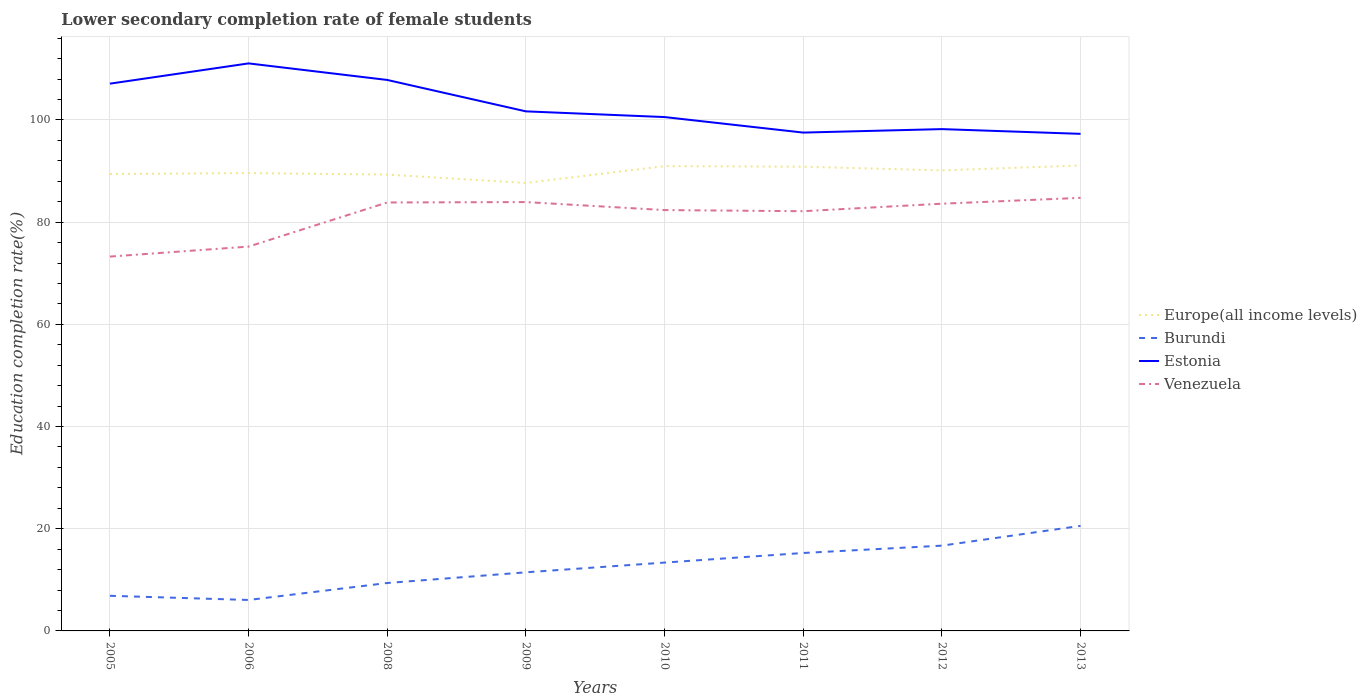Is the number of lines equal to the number of legend labels?
Keep it short and to the point. Yes. Across all years, what is the maximum lower secondary completion rate of female students in Venezuela?
Your response must be concise. 73.26. What is the total lower secondary completion rate of female students in Burundi in the graph?
Offer a very short reply. -5.41. What is the difference between the highest and the second highest lower secondary completion rate of female students in Burundi?
Offer a terse response. 14.5. How many lines are there?
Make the answer very short. 4. Where does the legend appear in the graph?
Offer a very short reply. Center right. How are the legend labels stacked?
Make the answer very short. Vertical. What is the title of the graph?
Your answer should be very brief. Lower secondary completion rate of female students. What is the label or title of the X-axis?
Give a very brief answer. Years. What is the label or title of the Y-axis?
Provide a succinct answer. Education completion rate(%). What is the Education completion rate(%) in Europe(all income levels) in 2005?
Provide a succinct answer. 89.41. What is the Education completion rate(%) in Burundi in 2005?
Make the answer very short. 6.87. What is the Education completion rate(%) in Estonia in 2005?
Your answer should be compact. 107.1. What is the Education completion rate(%) in Venezuela in 2005?
Your answer should be compact. 73.26. What is the Education completion rate(%) in Europe(all income levels) in 2006?
Make the answer very short. 89.6. What is the Education completion rate(%) of Burundi in 2006?
Make the answer very short. 6.06. What is the Education completion rate(%) of Estonia in 2006?
Offer a very short reply. 111.06. What is the Education completion rate(%) of Venezuela in 2006?
Offer a very short reply. 75.21. What is the Education completion rate(%) in Europe(all income levels) in 2008?
Your answer should be compact. 89.31. What is the Education completion rate(%) in Burundi in 2008?
Give a very brief answer. 9.38. What is the Education completion rate(%) in Estonia in 2008?
Offer a very short reply. 107.82. What is the Education completion rate(%) in Venezuela in 2008?
Provide a succinct answer. 83.84. What is the Education completion rate(%) of Europe(all income levels) in 2009?
Give a very brief answer. 87.66. What is the Education completion rate(%) in Burundi in 2009?
Ensure brevity in your answer.  11.47. What is the Education completion rate(%) in Estonia in 2009?
Keep it short and to the point. 101.68. What is the Education completion rate(%) in Venezuela in 2009?
Make the answer very short. 83.92. What is the Education completion rate(%) in Europe(all income levels) in 2010?
Offer a terse response. 90.96. What is the Education completion rate(%) of Burundi in 2010?
Your answer should be compact. 13.37. What is the Education completion rate(%) of Estonia in 2010?
Provide a succinct answer. 100.56. What is the Education completion rate(%) of Venezuela in 2010?
Your answer should be very brief. 82.36. What is the Education completion rate(%) in Europe(all income levels) in 2011?
Ensure brevity in your answer.  90.84. What is the Education completion rate(%) in Burundi in 2011?
Offer a terse response. 15.25. What is the Education completion rate(%) in Estonia in 2011?
Offer a terse response. 97.52. What is the Education completion rate(%) of Venezuela in 2011?
Keep it short and to the point. 82.14. What is the Education completion rate(%) of Europe(all income levels) in 2012?
Give a very brief answer. 90.13. What is the Education completion rate(%) of Burundi in 2012?
Keep it short and to the point. 16.69. What is the Education completion rate(%) of Estonia in 2012?
Provide a short and direct response. 98.2. What is the Education completion rate(%) of Venezuela in 2012?
Keep it short and to the point. 83.61. What is the Education completion rate(%) of Europe(all income levels) in 2013?
Offer a terse response. 91.08. What is the Education completion rate(%) of Burundi in 2013?
Make the answer very short. 20.56. What is the Education completion rate(%) of Estonia in 2013?
Make the answer very short. 97.27. What is the Education completion rate(%) in Venezuela in 2013?
Your answer should be very brief. 84.75. Across all years, what is the maximum Education completion rate(%) of Europe(all income levels)?
Your answer should be compact. 91.08. Across all years, what is the maximum Education completion rate(%) of Burundi?
Ensure brevity in your answer.  20.56. Across all years, what is the maximum Education completion rate(%) of Estonia?
Ensure brevity in your answer.  111.06. Across all years, what is the maximum Education completion rate(%) of Venezuela?
Provide a short and direct response. 84.75. Across all years, what is the minimum Education completion rate(%) in Europe(all income levels)?
Ensure brevity in your answer.  87.66. Across all years, what is the minimum Education completion rate(%) in Burundi?
Your answer should be very brief. 6.06. Across all years, what is the minimum Education completion rate(%) of Estonia?
Your response must be concise. 97.27. Across all years, what is the minimum Education completion rate(%) of Venezuela?
Provide a succinct answer. 73.26. What is the total Education completion rate(%) in Europe(all income levels) in the graph?
Your response must be concise. 718.99. What is the total Education completion rate(%) of Burundi in the graph?
Provide a succinct answer. 99.65. What is the total Education completion rate(%) of Estonia in the graph?
Offer a very short reply. 821.22. What is the total Education completion rate(%) of Venezuela in the graph?
Provide a succinct answer. 649.09. What is the difference between the Education completion rate(%) in Europe(all income levels) in 2005 and that in 2006?
Keep it short and to the point. -0.19. What is the difference between the Education completion rate(%) of Burundi in 2005 and that in 2006?
Ensure brevity in your answer.  0.82. What is the difference between the Education completion rate(%) of Estonia in 2005 and that in 2006?
Offer a very short reply. -3.96. What is the difference between the Education completion rate(%) in Venezuela in 2005 and that in 2006?
Make the answer very short. -1.95. What is the difference between the Education completion rate(%) of Europe(all income levels) in 2005 and that in 2008?
Your answer should be compact. 0.11. What is the difference between the Education completion rate(%) in Burundi in 2005 and that in 2008?
Provide a short and direct response. -2.5. What is the difference between the Education completion rate(%) of Estonia in 2005 and that in 2008?
Provide a short and direct response. -0.73. What is the difference between the Education completion rate(%) in Venezuela in 2005 and that in 2008?
Provide a short and direct response. -10.59. What is the difference between the Education completion rate(%) in Europe(all income levels) in 2005 and that in 2009?
Make the answer very short. 1.75. What is the difference between the Education completion rate(%) of Burundi in 2005 and that in 2009?
Your answer should be very brief. -4.6. What is the difference between the Education completion rate(%) in Estonia in 2005 and that in 2009?
Provide a succinct answer. 5.42. What is the difference between the Education completion rate(%) of Venezuela in 2005 and that in 2009?
Offer a terse response. -10.66. What is the difference between the Education completion rate(%) in Europe(all income levels) in 2005 and that in 2010?
Provide a succinct answer. -1.55. What is the difference between the Education completion rate(%) of Burundi in 2005 and that in 2010?
Make the answer very short. -6.5. What is the difference between the Education completion rate(%) in Estonia in 2005 and that in 2010?
Make the answer very short. 6.54. What is the difference between the Education completion rate(%) of Venezuela in 2005 and that in 2010?
Ensure brevity in your answer.  -9.1. What is the difference between the Education completion rate(%) in Europe(all income levels) in 2005 and that in 2011?
Keep it short and to the point. -1.43. What is the difference between the Education completion rate(%) of Burundi in 2005 and that in 2011?
Offer a very short reply. -8.38. What is the difference between the Education completion rate(%) of Estonia in 2005 and that in 2011?
Make the answer very short. 9.57. What is the difference between the Education completion rate(%) in Venezuela in 2005 and that in 2011?
Your response must be concise. -8.88. What is the difference between the Education completion rate(%) of Europe(all income levels) in 2005 and that in 2012?
Offer a very short reply. -0.71. What is the difference between the Education completion rate(%) of Burundi in 2005 and that in 2012?
Provide a short and direct response. -9.81. What is the difference between the Education completion rate(%) of Estonia in 2005 and that in 2012?
Your answer should be very brief. 8.89. What is the difference between the Education completion rate(%) in Venezuela in 2005 and that in 2012?
Give a very brief answer. -10.35. What is the difference between the Education completion rate(%) in Europe(all income levels) in 2005 and that in 2013?
Offer a terse response. -1.67. What is the difference between the Education completion rate(%) in Burundi in 2005 and that in 2013?
Ensure brevity in your answer.  -13.69. What is the difference between the Education completion rate(%) of Estonia in 2005 and that in 2013?
Ensure brevity in your answer.  9.82. What is the difference between the Education completion rate(%) of Venezuela in 2005 and that in 2013?
Your answer should be compact. -11.49. What is the difference between the Education completion rate(%) in Europe(all income levels) in 2006 and that in 2008?
Your answer should be very brief. 0.29. What is the difference between the Education completion rate(%) of Burundi in 2006 and that in 2008?
Give a very brief answer. -3.32. What is the difference between the Education completion rate(%) of Estonia in 2006 and that in 2008?
Keep it short and to the point. 3.24. What is the difference between the Education completion rate(%) in Venezuela in 2006 and that in 2008?
Your answer should be compact. -8.63. What is the difference between the Education completion rate(%) in Europe(all income levels) in 2006 and that in 2009?
Provide a short and direct response. 1.93. What is the difference between the Education completion rate(%) in Burundi in 2006 and that in 2009?
Give a very brief answer. -5.41. What is the difference between the Education completion rate(%) in Estonia in 2006 and that in 2009?
Offer a terse response. 9.39. What is the difference between the Education completion rate(%) in Venezuela in 2006 and that in 2009?
Your response must be concise. -8.71. What is the difference between the Education completion rate(%) of Europe(all income levels) in 2006 and that in 2010?
Your answer should be compact. -1.36. What is the difference between the Education completion rate(%) of Burundi in 2006 and that in 2010?
Ensure brevity in your answer.  -7.32. What is the difference between the Education completion rate(%) of Estonia in 2006 and that in 2010?
Give a very brief answer. 10.5. What is the difference between the Education completion rate(%) in Venezuela in 2006 and that in 2010?
Your response must be concise. -7.14. What is the difference between the Education completion rate(%) of Europe(all income levels) in 2006 and that in 2011?
Give a very brief answer. -1.25. What is the difference between the Education completion rate(%) in Burundi in 2006 and that in 2011?
Your answer should be very brief. -9.2. What is the difference between the Education completion rate(%) of Estonia in 2006 and that in 2011?
Make the answer very short. 13.54. What is the difference between the Education completion rate(%) in Venezuela in 2006 and that in 2011?
Give a very brief answer. -6.92. What is the difference between the Education completion rate(%) of Europe(all income levels) in 2006 and that in 2012?
Ensure brevity in your answer.  -0.53. What is the difference between the Education completion rate(%) of Burundi in 2006 and that in 2012?
Keep it short and to the point. -10.63. What is the difference between the Education completion rate(%) of Estonia in 2006 and that in 2012?
Provide a succinct answer. 12.86. What is the difference between the Education completion rate(%) in Venezuela in 2006 and that in 2012?
Keep it short and to the point. -8.39. What is the difference between the Education completion rate(%) of Europe(all income levels) in 2006 and that in 2013?
Offer a terse response. -1.49. What is the difference between the Education completion rate(%) in Burundi in 2006 and that in 2013?
Keep it short and to the point. -14.5. What is the difference between the Education completion rate(%) of Estonia in 2006 and that in 2013?
Offer a terse response. 13.79. What is the difference between the Education completion rate(%) of Venezuela in 2006 and that in 2013?
Give a very brief answer. -9.54. What is the difference between the Education completion rate(%) in Europe(all income levels) in 2008 and that in 2009?
Your answer should be compact. 1.64. What is the difference between the Education completion rate(%) in Burundi in 2008 and that in 2009?
Your response must be concise. -2.09. What is the difference between the Education completion rate(%) of Estonia in 2008 and that in 2009?
Give a very brief answer. 6.15. What is the difference between the Education completion rate(%) in Venezuela in 2008 and that in 2009?
Your answer should be compact. -0.08. What is the difference between the Education completion rate(%) in Europe(all income levels) in 2008 and that in 2010?
Your answer should be compact. -1.66. What is the difference between the Education completion rate(%) of Burundi in 2008 and that in 2010?
Provide a short and direct response. -4. What is the difference between the Education completion rate(%) in Estonia in 2008 and that in 2010?
Provide a short and direct response. 7.26. What is the difference between the Education completion rate(%) of Venezuela in 2008 and that in 2010?
Make the answer very short. 1.49. What is the difference between the Education completion rate(%) in Europe(all income levels) in 2008 and that in 2011?
Offer a terse response. -1.54. What is the difference between the Education completion rate(%) in Burundi in 2008 and that in 2011?
Ensure brevity in your answer.  -5.88. What is the difference between the Education completion rate(%) of Estonia in 2008 and that in 2011?
Provide a short and direct response. 10.3. What is the difference between the Education completion rate(%) in Venezuela in 2008 and that in 2011?
Offer a terse response. 1.71. What is the difference between the Education completion rate(%) in Europe(all income levels) in 2008 and that in 2012?
Offer a very short reply. -0.82. What is the difference between the Education completion rate(%) in Burundi in 2008 and that in 2012?
Your response must be concise. -7.31. What is the difference between the Education completion rate(%) of Estonia in 2008 and that in 2012?
Make the answer very short. 9.62. What is the difference between the Education completion rate(%) of Venezuela in 2008 and that in 2012?
Your response must be concise. 0.24. What is the difference between the Education completion rate(%) in Europe(all income levels) in 2008 and that in 2013?
Offer a very short reply. -1.78. What is the difference between the Education completion rate(%) in Burundi in 2008 and that in 2013?
Provide a short and direct response. -11.18. What is the difference between the Education completion rate(%) of Estonia in 2008 and that in 2013?
Provide a short and direct response. 10.55. What is the difference between the Education completion rate(%) in Venezuela in 2008 and that in 2013?
Provide a succinct answer. -0.91. What is the difference between the Education completion rate(%) in Europe(all income levels) in 2009 and that in 2010?
Keep it short and to the point. -3.3. What is the difference between the Education completion rate(%) in Burundi in 2009 and that in 2010?
Keep it short and to the point. -1.9. What is the difference between the Education completion rate(%) of Estonia in 2009 and that in 2010?
Ensure brevity in your answer.  1.12. What is the difference between the Education completion rate(%) of Venezuela in 2009 and that in 2010?
Offer a very short reply. 1.57. What is the difference between the Education completion rate(%) in Europe(all income levels) in 2009 and that in 2011?
Keep it short and to the point. -3.18. What is the difference between the Education completion rate(%) of Burundi in 2009 and that in 2011?
Ensure brevity in your answer.  -3.78. What is the difference between the Education completion rate(%) of Estonia in 2009 and that in 2011?
Provide a succinct answer. 4.15. What is the difference between the Education completion rate(%) of Venezuela in 2009 and that in 2011?
Provide a succinct answer. 1.79. What is the difference between the Education completion rate(%) in Europe(all income levels) in 2009 and that in 2012?
Your response must be concise. -2.46. What is the difference between the Education completion rate(%) in Burundi in 2009 and that in 2012?
Your response must be concise. -5.22. What is the difference between the Education completion rate(%) in Estonia in 2009 and that in 2012?
Give a very brief answer. 3.47. What is the difference between the Education completion rate(%) of Venezuela in 2009 and that in 2012?
Your answer should be compact. 0.32. What is the difference between the Education completion rate(%) of Europe(all income levels) in 2009 and that in 2013?
Provide a short and direct response. -3.42. What is the difference between the Education completion rate(%) of Burundi in 2009 and that in 2013?
Keep it short and to the point. -9.09. What is the difference between the Education completion rate(%) in Estonia in 2009 and that in 2013?
Give a very brief answer. 4.4. What is the difference between the Education completion rate(%) in Venezuela in 2009 and that in 2013?
Give a very brief answer. -0.83. What is the difference between the Education completion rate(%) in Europe(all income levels) in 2010 and that in 2011?
Keep it short and to the point. 0.12. What is the difference between the Education completion rate(%) of Burundi in 2010 and that in 2011?
Give a very brief answer. -1.88. What is the difference between the Education completion rate(%) in Estonia in 2010 and that in 2011?
Your answer should be compact. 3.04. What is the difference between the Education completion rate(%) in Venezuela in 2010 and that in 2011?
Provide a succinct answer. 0.22. What is the difference between the Education completion rate(%) of Europe(all income levels) in 2010 and that in 2012?
Your answer should be compact. 0.84. What is the difference between the Education completion rate(%) in Burundi in 2010 and that in 2012?
Offer a terse response. -3.31. What is the difference between the Education completion rate(%) of Estonia in 2010 and that in 2012?
Make the answer very short. 2.36. What is the difference between the Education completion rate(%) of Venezuela in 2010 and that in 2012?
Your answer should be very brief. -1.25. What is the difference between the Education completion rate(%) in Europe(all income levels) in 2010 and that in 2013?
Offer a very short reply. -0.12. What is the difference between the Education completion rate(%) in Burundi in 2010 and that in 2013?
Your answer should be very brief. -7.19. What is the difference between the Education completion rate(%) of Estonia in 2010 and that in 2013?
Offer a very short reply. 3.29. What is the difference between the Education completion rate(%) of Venezuela in 2010 and that in 2013?
Offer a terse response. -2.39. What is the difference between the Education completion rate(%) of Europe(all income levels) in 2011 and that in 2012?
Your answer should be compact. 0.72. What is the difference between the Education completion rate(%) in Burundi in 2011 and that in 2012?
Your answer should be very brief. -1.43. What is the difference between the Education completion rate(%) in Estonia in 2011 and that in 2012?
Your response must be concise. -0.68. What is the difference between the Education completion rate(%) of Venezuela in 2011 and that in 2012?
Make the answer very short. -1.47. What is the difference between the Education completion rate(%) of Europe(all income levels) in 2011 and that in 2013?
Your answer should be very brief. -0.24. What is the difference between the Education completion rate(%) of Burundi in 2011 and that in 2013?
Your answer should be compact. -5.31. What is the difference between the Education completion rate(%) of Estonia in 2011 and that in 2013?
Provide a succinct answer. 0.25. What is the difference between the Education completion rate(%) in Venezuela in 2011 and that in 2013?
Keep it short and to the point. -2.61. What is the difference between the Education completion rate(%) of Europe(all income levels) in 2012 and that in 2013?
Keep it short and to the point. -0.96. What is the difference between the Education completion rate(%) in Burundi in 2012 and that in 2013?
Your answer should be very brief. -3.87. What is the difference between the Education completion rate(%) of Estonia in 2012 and that in 2013?
Offer a very short reply. 0.93. What is the difference between the Education completion rate(%) in Venezuela in 2012 and that in 2013?
Offer a terse response. -1.15. What is the difference between the Education completion rate(%) of Europe(all income levels) in 2005 and the Education completion rate(%) of Burundi in 2006?
Your answer should be very brief. 83.35. What is the difference between the Education completion rate(%) of Europe(all income levels) in 2005 and the Education completion rate(%) of Estonia in 2006?
Give a very brief answer. -21.65. What is the difference between the Education completion rate(%) in Europe(all income levels) in 2005 and the Education completion rate(%) in Venezuela in 2006?
Your response must be concise. 14.2. What is the difference between the Education completion rate(%) of Burundi in 2005 and the Education completion rate(%) of Estonia in 2006?
Make the answer very short. -104.19. What is the difference between the Education completion rate(%) in Burundi in 2005 and the Education completion rate(%) in Venezuela in 2006?
Your answer should be compact. -68.34. What is the difference between the Education completion rate(%) of Estonia in 2005 and the Education completion rate(%) of Venezuela in 2006?
Make the answer very short. 31.88. What is the difference between the Education completion rate(%) of Europe(all income levels) in 2005 and the Education completion rate(%) of Burundi in 2008?
Ensure brevity in your answer.  80.03. What is the difference between the Education completion rate(%) of Europe(all income levels) in 2005 and the Education completion rate(%) of Estonia in 2008?
Your answer should be very brief. -18.41. What is the difference between the Education completion rate(%) of Europe(all income levels) in 2005 and the Education completion rate(%) of Venezuela in 2008?
Your response must be concise. 5.57. What is the difference between the Education completion rate(%) in Burundi in 2005 and the Education completion rate(%) in Estonia in 2008?
Your answer should be very brief. -100.95. What is the difference between the Education completion rate(%) in Burundi in 2005 and the Education completion rate(%) in Venezuela in 2008?
Give a very brief answer. -76.97. What is the difference between the Education completion rate(%) in Estonia in 2005 and the Education completion rate(%) in Venezuela in 2008?
Provide a short and direct response. 23.25. What is the difference between the Education completion rate(%) in Europe(all income levels) in 2005 and the Education completion rate(%) in Burundi in 2009?
Make the answer very short. 77.94. What is the difference between the Education completion rate(%) of Europe(all income levels) in 2005 and the Education completion rate(%) of Estonia in 2009?
Offer a very short reply. -12.26. What is the difference between the Education completion rate(%) of Europe(all income levels) in 2005 and the Education completion rate(%) of Venezuela in 2009?
Give a very brief answer. 5.49. What is the difference between the Education completion rate(%) in Burundi in 2005 and the Education completion rate(%) in Estonia in 2009?
Your answer should be very brief. -94.8. What is the difference between the Education completion rate(%) in Burundi in 2005 and the Education completion rate(%) in Venezuela in 2009?
Your answer should be compact. -77.05. What is the difference between the Education completion rate(%) of Estonia in 2005 and the Education completion rate(%) of Venezuela in 2009?
Offer a very short reply. 23.17. What is the difference between the Education completion rate(%) in Europe(all income levels) in 2005 and the Education completion rate(%) in Burundi in 2010?
Ensure brevity in your answer.  76.04. What is the difference between the Education completion rate(%) in Europe(all income levels) in 2005 and the Education completion rate(%) in Estonia in 2010?
Give a very brief answer. -11.15. What is the difference between the Education completion rate(%) in Europe(all income levels) in 2005 and the Education completion rate(%) in Venezuela in 2010?
Provide a short and direct response. 7.06. What is the difference between the Education completion rate(%) of Burundi in 2005 and the Education completion rate(%) of Estonia in 2010?
Offer a terse response. -93.69. What is the difference between the Education completion rate(%) in Burundi in 2005 and the Education completion rate(%) in Venezuela in 2010?
Keep it short and to the point. -75.48. What is the difference between the Education completion rate(%) in Estonia in 2005 and the Education completion rate(%) in Venezuela in 2010?
Ensure brevity in your answer.  24.74. What is the difference between the Education completion rate(%) of Europe(all income levels) in 2005 and the Education completion rate(%) of Burundi in 2011?
Your response must be concise. 74.16. What is the difference between the Education completion rate(%) of Europe(all income levels) in 2005 and the Education completion rate(%) of Estonia in 2011?
Your answer should be very brief. -8.11. What is the difference between the Education completion rate(%) in Europe(all income levels) in 2005 and the Education completion rate(%) in Venezuela in 2011?
Your answer should be very brief. 7.27. What is the difference between the Education completion rate(%) of Burundi in 2005 and the Education completion rate(%) of Estonia in 2011?
Provide a short and direct response. -90.65. What is the difference between the Education completion rate(%) in Burundi in 2005 and the Education completion rate(%) in Venezuela in 2011?
Provide a succinct answer. -75.26. What is the difference between the Education completion rate(%) of Estonia in 2005 and the Education completion rate(%) of Venezuela in 2011?
Offer a terse response. 24.96. What is the difference between the Education completion rate(%) in Europe(all income levels) in 2005 and the Education completion rate(%) in Burundi in 2012?
Provide a short and direct response. 72.72. What is the difference between the Education completion rate(%) of Europe(all income levels) in 2005 and the Education completion rate(%) of Estonia in 2012?
Your answer should be very brief. -8.79. What is the difference between the Education completion rate(%) in Europe(all income levels) in 2005 and the Education completion rate(%) in Venezuela in 2012?
Provide a succinct answer. 5.81. What is the difference between the Education completion rate(%) of Burundi in 2005 and the Education completion rate(%) of Estonia in 2012?
Provide a succinct answer. -91.33. What is the difference between the Education completion rate(%) in Burundi in 2005 and the Education completion rate(%) in Venezuela in 2012?
Your response must be concise. -76.73. What is the difference between the Education completion rate(%) of Estonia in 2005 and the Education completion rate(%) of Venezuela in 2012?
Provide a short and direct response. 23.49. What is the difference between the Education completion rate(%) of Europe(all income levels) in 2005 and the Education completion rate(%) of Burundi in 2013?
Provide a succinct answer. 68.85. What is the difference between the Education completion rate(%) of Europe(all income levels) in 2005 and the Education completion rate(%) of Estonia in 2013?
Offer a terse response. -7.86. What is the difference between the Education completion rate(%) of Europe(all income levels) in 2005 and the Education completion rate(%) of Venezuela in 2013?
Offer a terse response. 4.66. What is the difference between the Education completion rate(%) in Burundi in 2005 and the Education completion rate(%) in Estonia in 2013?
Your answer should be compact. -90.4. What is the difference between the Education completion rate(%) in Burundi in 2005 and the Education completion rate(%) in Venezuela in 2013?
Keep it short and to the point. -77.88. What is the difference between the Education completion rate(%) in Estonia in 2005 and the Education completion rate(%) in Venezuela in 2013?
Keep it short and to the point. 22.35. What is the difference between the Education completion rate(%) of Europe(all income levels) in 2006 and the Education completion rate(%) of Burundi in 2008?
Offer a very short reply. 80.22. What is the difference between the Education completion rate(%) of Europe(all income levels) in 2006 and the Education completion rate(%) of Estonia in 2008?
Keep it short and to the point. -18.23. What is the difference between the Education completion rate(%) of Europe(all income levels) in 2006 and the Education completion rate(%) of Venezuela in 2008?
Your response must be concise. 5.75. What is the difference between the Education completion rate(%) in Burundi in 2006 and the Education completion rate(%) in Estonia in 2008?
Keep it short and to the point. -101.77. What is the difference between the Education completion rate(%) of Burundi in 2006 and the Education completion rate(%) of Venezuela in 2008?
Keep it short and to the point. -77.79. What is the difference between the Education completion rate(%) in Estonia in 2006 and the Education completion rate(%) in Venezuela in 2008?
Your answer should be very brief. 27.22. What is the difference between the Education completion rate(%) of Europe(all income levels) in 2006 and the Education completion rate(%) of Burundi in 2009?
Your answer should be very brief. 78.13. What is the difference between the Education completion rate(%) of Europe(all income levels) in 2006 and the Education completion rate(%) of Estonia in 2009?
Give a very brief answer. -12.08. What is the difference between the Education completion rate(%) in Europe(all income levels) in 2006 and the Education completion rate(%) in Venezuela in 2009?
Your answer should be very brief. 5.67. What is the difference between the Education completion rate(%) of Burundi in 2006 and the Education completion rate(%) of Estonia in 2009?
Your answer should be very brief. -95.62. What is the difference between the Education completion rate(%) in Burundi in 2006 and the Education completion rate(%) in Venezuela in 2009?
Your answer should be very brief. -77.87. What is the difference between the Education completion rate(%) in Estonia in 2006 and the Education completion rate(%) in Venezuela in 2009?
Offer a terse response. 27.14. What is the difference between the Education completion rate(%) in Europe(all income levels) in 2006 and the Education completion rate(%) in Burundi in 2010?
Your response must be concise. 76.22. What is the difference between the Education completion rate(%) of Europe(all income levels) in 2006 and the Education completion rate(%) of Estonia in 2010?
Offer a terse response. -10.96. What is the difference between the Education completion rate(%) of Europe(all income levels) in 2006 and the Education completion rate(%) of Venezuela in 2010?
Offer a terse response. 7.24. What is the difference between the Education completion rate(%) in Burundi in 2006 and the Education completion rate(%) in Estonia in 2010?
Your answer should be compact. -94.5. What is the difference between the Education completion rate(%) in Burundi in 2006 and the Education completion rate(%) in Venezuela in 2010?
Your answer should be very brief. -76.3. What is the difference between the Education completion rate(%) of Estonia in 2006 and the Education completion rate(%) of Venezuela in 2010?
Give a very brief answer. 28.7. What is the difference between the Education completion rate(%) in Europe(all income levels) in 2006 and the Education completion rate(%) in Burundi in 2011?
Provide a succinct answer. 74.34. What is the difference between the Education completion rate(%) of Europe(all income levels) in 2006 and the Education completion rate(%) of Estonia in 2011?
Make the answer very short. -7.93. What is the difference between the Education completion rate(%) in Europe(all income levels) in 2006 and the Education completion rate(%) in Venezuela in 2011?
Offer a terse response. 7.46. What is the difference between the Education completion rate(%) of Burundi in 2006 and the Education completion rate(%) of Estonia in 2011?
Make the answer very short. -91.47. What is the difference between the Education completion rate(%) in Burundi in 2006 and the Education completion rate(%) in Venezuela in 2011?
Ensure brevity in your answer.  -76.08. What is the difference between the Education completion rate(%) of Estonia in 2006 and the Education completion rate(%) of Venezuela in 2011?
Give a very brief answer. 28.92. What is the difference between the Education completion rate(%) in Europe(all income levels) in 2006 and the Education completion rate(%) in Burundi in 2012?
Provide a succinct answer. 72.91. What is the difference between the Education completion rate(%) in Europe(all income levels) in 2006 and the Education completion rate(%) in Estonia in 2012?
Make the answer very short. -8.61. What is the difference between the Education completion rate(%) of Europe(all income levels) in 2006 and the Education completion rate(%) of Venezuela in 2012?
Your answer should be compact. 5.99. What is the difference between the Education completion rate(%) of Burundi in 2006 and the Education completion rate(%) of Estonia in 2012?
Ensure brevity in your answer.  -92.15. What is the difference between the Education completion rate(%) in Burundi in 2006 and the Education completion rate(%) in Venezuela in 2012?
Offer a very short reply. -77.55. What is the difference between the Education completion rate(%) in Estonia in 2006 and the Education completion rate(%) in Venezuela in 2012?
Ensure brevity in your answer.  27.46. What is the difference between the Education completion rate(%) of Europe(all income levels) in 2006 and the Education completion rate(%) of Burundi in 2013?
Offer a very short reply. 69.04. What is the difference between the Education completion rate(%) of Europe(all income levels) in 2006 and the Education completion rate(%) of Estonia in 2013?
Your answer should be very brief. -7.68. What is the difference between the Education completion rate(%) of Europe(all income levels) in 2006 and the Education completion rate(%) of Venezuela in 2013?
Your answer should be compact. 4.85. What is the difference between the Education completion rate(%) in Burundi in 2006 and the Education completion rate(%) in Estonia in 2013?
Provide a succinct answer. -91.22. What is the difference between the Education completion rate(%) in Burundi in 2006 and the Education completion rate(%) in Venezuela in 2013?
Provide a short and direct response. -78.69. What is the difference between the Education completion rate(%) of Estonia in 2006 and the Education completion rate(%) of Venezuela in 2013?
Ensure brevity in your answer.  26.31. What is the difference between the Education completion rate(%) in Europe(all income levels) in 2008 and the Education completion rate(%) in Burundi in 2009?
Ensure brevity in your answer.  77.84. What is the difference between the Education completion rate(%) of Europe(all income levels) in 2008 and the Education completion rate(%) of Estonia in 2009?
Provide a short and direct response. -12.37. What is the difference between the Education completion rate(%) in Europe(all income levels) in 2008 and the Education completion rate(%) in Venezuela in 2009?
Offer a terse response. 5.38. What is the difference between the Education completion rate(%) of Burundi in 2008 and the Education completion rate(%) of Estonia in 2009?
Your answer should be compact. -92.3. What is the difference between the Education completion rate(%) in Burundi in 2008 and the Education completion rate(%) in Venezuela in 2009?
Offer a terse response. -74.54. What is the difference between the Education completion rate(%) in Estonia in 2008 and the Education completion rate(%) in Venezuela in 2009?
Give a very brief answer. 23.9. What is the difference between the Education completion rate(%) of Europe(all income levels) in 2008 and the Education completion rate(%) of Burundi in 2010?
Keep it short and to the point. 75.93. What is the difference between the Education completion rate(%) in Europe(all income levels) in 2008 and the Education completion rate(%) in Estonia in 2010?
Provide a succinct answer. -11.25. What is the difference between the Education completion rate(%) of Europe(all income levels) in 2008 and the Education completion rate(%) of Venezuela in 2010?
Make the answer very short. 6.95. What is the difference between the Education completion rate(%) in Burundi in 2008 and the Education completion rate(%) in Estonia in 2010?
Give a very brief answer. -91.18. What is the difference between the Education completion rate(%) of Burundi in 2008 and the Education completion rate(%) of Venezuela in 2010?
Offer a very short reply. -72.98. What is the difference between the Education completion rate(%) in Estonia in 2008 and the Education completion rate(%) in Venezuela in 2010?
Offer a terse response. 25.47. What is the difference between the Education completion rate(%) of Europe(all income levels) in 2008 and the Education completion rate(%) of Burundi in 2011?
Make the answer very short. 74.05. What is the difference between the Education completion rate(%) in Europe(all income levels) in 2008 and the Education completion rate(%) in Estonia in 2011?
Give a very brief answer. -8.22. What is the difference between the Education completion rate(%) of Europe(all income levels) in 2008 and the Education completion rate(%) of Venezuela in 2011?
Give a very brief answer. 7.17. What is the difference between the Education completion rate(%) in Burundi in 2008 and the Education completion rate(%) in Estonia in 2011?
Keep it short and to the point. -88.14. What is the difference between the Education completion rate(%) in Burundi in 2008 and the Education completion rate(%) in Venezuela in 2011?
Provide a succinct answer. -72.76. What is the difference between the Education completion rate(%) of Estonia in 2008 and the Education completion rate(%) of Venezuela in 2011?
Your answer should be compact. 25.68. What is the difference between the Education completion rate(%) of Europe(all income levels) in 2008 and the Education completion rate(%) of Burundi in 2012?
Make the answer very short. 72.62. What is the difference between the Education completion rate(%) in Europe(all income levels) in 2008 and the Education completion rate(%) in Estonia in 2012?
Offer a very short reply. -8.9. What is the difference between the Education completion rate(%) of Europe(all income levels) in 2008 and the Education completion rate(%) of Venezuela in 2012?
Ensure brevity in your answer.  5.7. What is the difference between the Education completion rate(%) in Burundi in 2008 and the Education completion rate(%) in Estonia in 2012?
Provide a short and direct response. -88.83. What is the difference between the Education completion rate(%) in Burundi in 2008 and the Education completion rate(%) in Venezuela in 2012?
Give a very brief answer. -74.23. What is the difference between the Education completion rate(%) of Estonia in 2008 and the Education completion rate(%) of Venezuela in 2012?
Provide a succinct answer. 24.22. What is the difference between the Education completion rate(%) in Europe(all income levels) in 2008 and the Education completion rate(%) in Burundi in 2013?
Your answer should be very brief. 68.75. What is the difference between the Education completion rate(%) in Europe(all income levels) in 2008 and the Education completion rate(%) in Estonia in 2013?
Make the answer very short. -7.97. What is the difference between the Education completion rate(%) in Europe(all income levels) in 2008 and the Education completion rate(%) in Venezuela in 2013?
Provide a short and direct response. 4.55. What is the difference between the Education completion rate(%) of Burundi in 2008 and the Education completion rate(%) of Estonia in 2013?
Your answer should be compact. -87.9. What is the difference between the Education completion rate(%) of Burundi in 2008 and the Education completion rate(%) of Venezuela in 2013?
Give a very brief answer. -75.37. What is the difference between the Education completion rate(%) in Estonia in 2008 and the Education completion rate(%) in Venezuela in 2013?
Your answer should be compact. 23.07. What is the difference between the Education completion rate(%) of Europe(all income levels) in 2009 and the Education completion rate(%) of Burundi in 2010?
Give a very brief answer. 74.29. What is the difference between the Education completion rate(%) of Europe(all income levels) in 2009 and the Education completion rate(%) of Estonia in 2010?
Provide a succinct answer. -12.9. What is the difference between the Education completion rate(%) of Europe(all income levels) in 2009 and the Education completion rate(%) of Venezuela in 2010?
Offer a terse response. 5.31. What is the difference between the Education completion rate(%) in Burundi in 2009 and the Education completion rate(%) in Estonia in 2010?
Ensure brevity in your answer.  -89.09. What is the difference between the Education completion rate(%) of Burundi in 2009 and the Education completion rate(%) of Venezuela in 2010?
Your answer should be compact. -70.89. What is the difference between the Education completion rate(%) in Estonia in 2009 and the Education completion rate(%) in Venezuela in 2010?
Give a very brief answer. 19.32. What is the difference between the Education completion rate(%) in Europe(all income levels) in 2009 and the Education completion rate(%) in Burundi in 2011?
Make the answer very short. 72.41. What is the difference between the Education completion rate(%) of Europe(all income levels) in 2009 and the Education completion rate(%) of Estonia in 2011?
Your response must be concise. -9.86. What is the difference between the Education completion rate(%) of Europe(all income levels) in 2009 and the Education completion rate(%) of Venezuela in 2011?
Your answer should be very brief. 5.53. What is the difference between the Education completion rate(%) in Burundi in 2009 and the Education completion rate(%) in Estonia in 2011?
Ensure brevity in your answer.  -86.05. What is the difference between the Education completion rate(%) in Burundi in 2009 and the Education completion rate(%) in Venezuela in 2011?
Provide a short and direct response. -70.67. What is the difference between the Education completion rate(%) in Estonia in 2009 and the Education completion rate(%) in Venezuela in 2011?
Offer a terse response. 19.54. What is the difference between the Education completion rate(%) of Europe(all income levels) in 2009 and the Education completion rate(%) of Burundi in 2012?
Provide a succinct answer. 70.98. What is the difference between the Education completion rate(%) in Europe(all income levels) in 2009 and the Education completion rate(%) in Estonia in 2012?
Offer a very short reply. -10.54. What is the difference between the Education completion rate(%) of Europe(all income levels) in 2009 and the Education completion rate(%) of Venezuela in 2012?
Keep it short and to the point. 4.06. What is the difference between the Education completion rate(%) in Burundi in 2009 and the Education completion rate(%) in Estonia in 2012?
Provide a succinct answer. -86.73. What is the difference between the Education completion rate(%) in Burundi in 2009 and the Education completion rate(%) in Venezuela in 2012?
Give a very brief answer. -72.14. What is the difference between the Education completion rate(%) in Estonia in 2009 and the Education completion rate(%) in Venezuela in 2012?
Ensure brevity in your answer.  18.07. What is the difference between the Education completion rate(%) in Europe(all income levels) in 2009 and the Education completion rate(%) in Burundi in 2013?
Provide a short and direct response. 67.1. What is the difference between the Education completion rate(%) of Europe(all income levels) in 2009 and the Education completion rate(%) of Estonia in 2013?
Make the answer very short. -9.61. What is the difference between the Education completion rate(%) in Europe(all income levels) in 2009 and the Education completion rate(%) in Venezuela in 2013?
Provide a succinct answer. 2.91. What is the difference between the Education completion rate(%) of Burundi in 2009 and the Education completion rate(%) of Estonia in 2013?
Make the answer very short. -85.8. What is the difference between the Education completion rate(%) in Burundi in 2009 and the Education completion rate(%) in Venezuela in 2013?
Keep it short and to the point. -73.28. What is the difference between the Education completion rate(%) of Estonia in 2009 and the Education completion rate(%) of Venezuela in 2013?
Your response must be concise. 16.92. What is the difference between the Education completion rate(%) of Europe(all income levels) in 2010 and the Education completion rate(%) of Burundi in 2011?
Provide a short and direct response. 75.71. What is the difference between the Education completion rate(%) of Europe(all income levels) in 2010 and the Education completion rate(%) of Estonia in 2011?
Keep it short and to the point. -6.56. What is the difference between the Education completion rate(%) in Europe(all income levels) in 2010 and the Education completion rate(%) in Venezuela in 2011?
Your answer should be compact. 8.82. What is the difference between the Education completion rate(%) of Burundi in 2010 and the Education completion rate(%) of Estonia in 2011?
Ensure brevity in your answer.  -84.15. What is the difference between the Education completion rate(%) in Burundi in 2010 and the Education completion rate(%) in Venezuela in 2011?
Provide a succinct answer. -68.76. What is the difference between the Education completion rate(%) of Estonia in 2010 and the Education completion rate(%) of Venezuela in 2011?
Provide a short and direct response. 18.42. What is the difference between the Education completion rate(%) of Europe(all income levels) in 2010 and the Education completion rate(%) of Burundi in 2012?
Your answer should be compact. 74.27. What is the difference between the Education completion rate(%) of Europe(all income levels) in 2010 and the Education completion rate(%) of Estonia in 2012?
Your answer should be very brief. -7.24. What is the difference between the Education completion rate(%) in Europe(all income levels) in 2010 and the Education completion rate(%) in Venezuela in 2012?
Make the answer very short. 7.36. What is the difference between the Education completion rate(%) of Burundi in 2010 and the Education completion rate(%) of Estonia in 2012?
Your answer should be compact. -84.83. What is the difference between the Education completion rate(%) of Burundi in 2010 and the Education completion rate(%) of Venezuela in 2012?
Your answer should be compact. -70.23. What is the difference between the Education completion rate(%) in Estonia in 2010 and the Education completion rate(%) in Venezuela in 2012?
Make the answer very short. 16.95. What is the difference between the Education completion rate(%) in Europe(all income levels) in 2010 and the Education completion rate(%) in Burundi in 2013?
Keep it short and to the point. 70.4. What is the difference between the Education completion rate(%) of Europe(all income levels) in 2010 and the Education completion rate(%) of Estonia in 2013?
Provide a short and direct response. -6.31. What is the difference between the Education completion rate(%) of Europe(all income levels) in 2010 and the Education completion rate(%) of Venezuela in 2013?
Provide a short and direct response. 6.21. What is the difference between the Education completion rate(%) in Burundi in 2010 and the Education completion rate(%) in Estonia in 2013?
Give a very brief answer. -83.9. What is the difference between the Education completion rate(%) in Burundi in 2010 and the Education completion rate(%) in Venezuela in 2013?
Make the answer very short. -71.38. What is the difference between the Education completion rate(%) in Estonia in 2010 and the Education completion rate(%) in Venezuela in 2013?
Ensure brevity in your answer.  15.81. What is the difference between the Education completion rate(%) of Europe(all income levels) in 2011 and the Education completion rate(%) of Burundi in 2012?
Provide a short and direct response. 74.16. What is the difference between the Education completion rate(%) of Europe(all income levels) in 2011 and the Education completion rate(%) of Estonia in 2012?
Offer a very short reply. -7.36. What is the difference between the Education completion rate(%) in Europe(all income levels) in 2011 and the Education completion rate(%) in Venezuela in 2012?
Your answer should be very brief. 7.24. What is the difference between the Education completion rate(%) in Burundi in 2011 and the Education completion rate(%) in Estonia in 2012?
Your response must be concise. -82.95. What is the difference between the Education completion rate(%) in Burundi in 2011 and the Education completion rate(%) in Venezuela in 2012?
Your response must be concise. -68.35. What is the difference between the Education completion rate(%) in Estonia in 2011 and the Education completion rate(%) in Venezuela in 2012?
Give a very brief answer. 13.92. What is the difference between the Education completion rate(%) in Europe(all income levels) in 2011 and the Education completion rate(%) in Burundi in 2013?
Give a very brief answer. 70.28. What is the difference between the Education completion rate(%) of Europe(all income levels) in 2011 and the Education completion rate(%) of Estonia in 2013?
Provide a short and direct response. -6.43. What is the difference between the Education completion rate(%) of Europe(all income levels) in 2011 and the Education completion rate(%) of Venezuela in 2013?
Offer a terse response. 6.09. What is the difference between the Education completion rate(%) of Burundi in 2011 and the Education completion rate(%) of Estonia in 2013?
Keep it short and to the point. -82.02. What is the difference between the Education completion rate(%) of Burundi in 2011 and the Education completion rate(%) of Venezuela in 2013?
Give a very brief answer. -69.5. What is the difference between the Education completion rate(%) in Estonia in 2011 and the Education completion rate(%) in Venezuela in 2013?
Offer a very short reply. 12.77. What is the difference between the Education completion rate(%) in Europe(all income levels) in 2012 and the Education completion rate(%) in Burundi in 2013?
Offer a terse response. 69.57. What is the difference between the Education completion rate(%) in Europe(all income levels) in 2012 and the Education completion rate(%) in Estonia in 2013?
Offer a terse response. -7.15. What is the difference between the Education completion rate(%) in Europe(all income levels) in 2012 and the Education completion rate(%) in Venezuela in 2013?
Your answer should be compact. 5.37. What is the difference between the Education completion rate(%) of Burundi in 2012 and the Education completion rate(%) of Estonia in 2013?
Your answer should be compact. -80.59. What is the difference between the Education completion rate(%) of Burundi in 2012 and the Education completion rate(%) of Venezuela in 2013?
Offer a terse response. -68.06. What is the difference between the Education completion rate(%) in Estonia in 2012 and the Education completion rate(%) in Venezuela in 2013?
Your answer should be very brief. 13.45. What is the average Education completion rate(%) of Europe(all income levels) per year?
Your answer should be compact. 89.87. What is the average Education completion rate(%) of Burundi per year?
Keep it short and to the point. 12.46. What is the average Education completion rate(%) of Estonia per year?
Give a very brief answer. 102.65. What is the average Education completion rate(%) in Venezuela per year?
Your response must be concise. 81.14. In the year 2005, what is the difference between the Education completion rate(%) of Europe(all income levels) and Education completion rate(%) of Burundi?
Provide a succinct answer. 82.54. In the year 2005, what is the difference between the Education completion rate(%) in Europe(all income levels) and Education completion rate(%) in Estonia?
Offer a terse response. -17.69. In the year 2005, what is the difference between the Education completion rate(%) of Europe(all income levels) and Education completion rate(%) of Venezuela?
Keep it short and to the point. 16.15. In the year 2005, what is the difference between the Education completion rate(%) in Burundi and Education completion rate(%) in Estonia?
Your answer should be very brief. -100.22. In the year 2005, what is the difference between the Education completion rate(%) of Burundi and Education completion rate(%) of Venezuela?
Provide a succinct answer. -66.39. In the year 2005, what is the difference between the Education completion rate(%) in Estonia and Education completion rate(%) in Venezuela?
Offer a very short reply. 33.84. In the year 2006, what is the difference between the Education completion rate(%) in Europe(all income levels) and Education completion rate(%) in Burundi?
Give a very brief answer. 83.54. In the year 2006, what is the difference between the Education completion rate(%) in Europe(all income levels) and Education completion rate(%) in Estonia?
Your answer should be compact. -21.46. In the year 2006, what is the difference between the Education completion rate(%) in Europe(all income levels) and Education completion rate(%) in Venezuela?
Offer a very short reply. 14.38. In the year 2006, what is the difference between the Education completion rate(%) of Burundi and Education completion rate(%) of Estonia?
Offer a very short reply. -105. In the year 2006, what is the difference between the Education completion rate(%) of Burundi and Education completion rate(%) of Venezuela?
Give a very brief answer. -69.16. In the year 2006, what is the difference between the Education completion rate(%) of Estonia and Education completion rate(%) of Venezuela?
Keep it short and to the point. 35.85. In the year 2008, what is the difference between the Education completion rate(%) of Europe(all income levels) and Education completion rate(%) of Burundi?
Provide a short and direct response. 79.93. In the year 2008, what is the difference between the Education completion rate(%) of Europe(all income levels) and Education completion rate(%) of Estonia?
Offer a terse response. -18.52. In the year 2008, what is the difference between the Education completion rate(%) in Europe(all income levels) and Education completion rate(%) in Venezuela?
Provide a succinct answer. 5.46. In the year 2008, what is the difference between the Education completion rate(%) of Burundi and Education completion rate(%) of Estonia?
Keep it short and to the point. -98.44. In the year 2008, what is the difference between the Education completion rate(%) of Burundi and Education completion rate(%) of Venezuela?
Keep it short and to the point. -74.47. In the year 2008, what is the difference between the Education completion rate(%) in Estonia and Education completion rate(%) in Venezuela?
Offer a very short reply. 23.98. In the year 2009, what is the difference between the Education completion rate(%) of Europe(all income levels) and Education completion rate(%) of Burundi?
Your answer should be compact. 76.19. In the year 2009, what is the difference between the Education completion rate(%) of Europe(all income levels) and Education completion rate(%) of Estonia?
Your response must be concise. -14.01. In the year 2009, what is the difference between the Education completion rate(%) in Europe(all income levels) and Education completion rate(%) in Venezuela?
Offer a very short reply. 3.74. In the year 2009, what is the difference between the Education completion rate(%) of Burundi and Education completion rate(%) of Estonia?
Your answer should be compact. -90.21. In the year 2009, what is the difference between the Education completion rate(%) of Burundi and Education completion rate(%) of Venezuela?
Your answer should be very brief. -72.45. In the year 2009, what is the difference between the Education completion rate(%) in Estonia and Education completion rate(%) in Venezuela?
Ensure brevity in your answer.  17.75. In the year 2010, what is the difference between the Education completion rate(%) in Europe(all income levels) and Education completion rate(%) in Burundi?
Your response must be concise. 77.59. In the year 2010, what is the difference between the Education completion rate(%) of Europe(all income levels) and Education completion rate(%) of Estonia?
Offer a terse response. -9.6. In the year 2010, what is the difference between the Education completion rate(%) of Europe(all income levels) and Education completion rate(%) of Venezuela?
Your answer should be compact. 8.6. In the year 2010, what is the difference between the Education completion rate(%) in Burundi and Education completion rate(%) in Estonia?
Provide a succinct answer. -87.19. In the year 2010, what is the difference between the Education completion rate(%) in Burundi and Education completion rate(%) in Venezuela?
Offer a terse response. -68.98. In the year 2010, what is the difference between the Education completion rate(%) in Estonia and Education completion rate(%) in Venezuela?
Your response must be concise. 18.2. In the year 2011, what is the difference between the Education completion rate(%) of Europe(all income levels) and Education completion rate(%) of Burundi?
Offer a terse response. 75.59. In the year 2011, what is the difference between the Education completion rate(%) of Europe(all income levels) and Education completion rate(%) of Estonia?
Your answer should be compact. -6.68. In the year 2011, what is the difference between the Education completion rate(%) of Europe(all income levels) and Education completion rate(%) of Venezuela?
Give a very brief answer. 8.71. In the year 2011, what is the difference between the Education completion rate(%) of Burundi and Education completion rate(%) of Estonia?
Your answer should be compact. -82.27. In the year 2011, what is the difference between the Education completion rate(%) in Burundi and Education completion rate(%) in Venezuela?
Offer a very short reply. -66.88. In the year 2011, what is the difference between the Education completion rate(%) of Estonia and Education completion rate(%) of Venezuela?
Your response must be concise. 15.39. In the year 2012, what is the difference between the Education completion rate(%) of Europe(all income levels) and Education completion rate(%) of Burundi?
Provide a short and direct response. 73.44. In the year 2012, what is the difference between the Education completion rate(%) of Europe(all income levels) and Education completion rate(%) of Estonia?
Make the answer very short. -8.08. In the year 2012, what is the difference between the Education completion rate(%) in Europe(all income levels) and Education completion rate(%) in Venezuela?
Make the answer very short. 6.52. In the year 2012, what is the difference between the Education completion rate(%) of Burundi and Education completion rate(%) of Estonia?
Keep it short and to the point. -81.52. In the year 2012, what is the difference between the Education completion rate(%) in Burundi and Education completion rate(%) in Venezuela?
Your answer should be compact. -66.92. In the year 2012, what is the difference between the Education completion rate(%) in Estonia and Education completion rate(%) in Venezuela?
Provide a short and direct response. 14.6. In the year 2013, what is the difference between the Education completion rate(%) in Europe(all income levels) and Education completion rate(%) in Burundi?
Provide a short and direct response. 70.52. In the year 2013, what is the difference between the Education completion rate(%) in Europe(all income levels) and Education completion rate(%) in Estonia?
Keep it short and to the point. -6.19. In the year 2013, what is the difference between the Education completion rate(%) in Europe(all income levels) and Education completion rate(%) in Venezuela?
Make the answer very short. 6.33. In the year 2013, what is the difference between the Education completion rate(%) of Burundi and Education completion rate(%) of Estonia?
Your answer should be very brief. -76.71. In the year 2013, what is the difference between the Education completion rate(%) in Burundi and Education completion rate(%) in Venezuela?
Ensure brevity in your answer.  -64.19. In the year 2013, what is the difference between the Education completion rate(%) in Estonia and Education completion rate(%) in Venezuela?
Give a very brief answer. 12.52. What is the ratio of the Education completion rate(%) in Burundi in 2005 to that in 2006?
Offer a terse response. 1.13. What is the ratio of the Education completion rate(%) in Burundi in 2005 to that in 2008?
Your answer should be compact. 0.73. What is the ratio of the Education completion rate(%) in Estonia in 2005 to that in 2008?
Your response must be concise. 0.99. What is the ratio of the Education completion rate(%) in Venezuela in 2005 to that in 2008?
Keep it short and to the point. 0.87. What is the ratio of the Education completion rate(%) in Europe(all income levels) in 2005 to that in 2009?
Provide a succinct answer. 1.02. What is the ratio of the Education completion rate(%) of Burundi in 2005 to that in 2009?
Your response must be concise. 0.6. What is the ratio of the Education completion rate(%) of Estonia in 2005 to that in 2009?
Make the answer very short. 1.05. What is the ratio of the Education completion rate(%) of Venezuela in 2005 to that in 2009?
Your answer should be very brief. 0.87. What is the ratio of the Education completion rate(%) of Burundi in 2005 to that in 2010?
Ensure brevity in your answer.  0.51. What is the ratio of the Education completion rate(%) of Estonia in 2005 to that in 2010?
Your response must be concise. 1.06. What is the ratio of the Education completion rate(%) in Venezuela in 2005 to that in 2010?
Keep it short and to the point. 0.89. What is the ratio of the Education completion rate(%) of Europe(all income levels) in 2005 to that in 2011?
Ensure brevity in your answer.  0.98. What is the ratio of the Education completion rate(%) of Burundi in 2005 to that in 2011?
Your answer should be very brief. 0.45. What is the ratio of the Education completion rate(%) in Estonia in 2005 to that in 2011?
Offer a very short reply. 1.1. What is the ratio of the Education completion rate(%) in Venezuela in 2005 to that in 2011?
Offer a very short reply. 0.89. What is the ratio of the Education completion rate(%) in Europe(all income levels) in 2005 to that in 2012?
Make the answer very short. 0.99. What is the ratio of the Education completion rate(%) of Burundi in 2005 to that in 2012?
Offer a terse response. 0.41. What is the ratio of the Education completion rate(%) in Estonia in 2005 to that in 2012?
Offer a very short reply. 1.09. What is the ratio of the Education completion rate(%) of Venezuela in 2005 to that in 2012?
Keep it short and to the point. 0.88. What is the ratio of the Education completion rate(%) in Europe(all income levels) in 2005 to that in 2013?
Make the answer very short. 0.98. What is the ratio of the Education completion rate(%) in Burundi in 2005 to that in 2013?
Provide a succinct answer. 0.33. What is the ratio of the Education completion rate(%) in Estonia in 2005 to that in 2013?
Provide a short and direct response. 1.1. What is the ratio of the Education completion rate(%) in Venezuela in 2005 to that in 2013?
Your answer should be very brief. 0.86. What is the ratio of the Education completion rate(%) of Europe(all income levels) in 2006 to that in 2008?
Your answer should be compact. 1. What is the ratio of the Education completion rate(%) of Burundi in 2006 to that in 2008?
Your answer should be compact. 0.65. What is the ratio of the Education completion rate(%) of Estonia in 2006 to that in 2008?
Provide a succinct answer. 1.03. What is the ratio of the Education completion rate(%) of Venezuela in 2006 to that in 2008?
Your response must be concise. 0.9. What is the ratio of the Education completion rate(%) in Europe(all income levels) in 2006 to that in 2009?
Offer a very short reply. 1.02. What is the ratio of the Education completion rate(%) in Burundi in 2006 to that in 2009?
Provide a short and direct response. 0.53. What is the ratio of the Education completion rate(%) of Estonia in 2006 to that in 2009?
Your answer should be compact. 1.09. What is the ratio of the Education completion rate(%) in Venezuela in 2006 to that in 2009?
Give a very brief answer. 0.9. What is the ratio of the Education completion rate(%) in Europe(all income levels) in 2006 to that in 2010?
Make the answer very short. 0.98. What is the ratio of the Education completion rate(%) in Burundi in 2006 to that in 2010?
Provide a short and direct response. 0.45. What is the ratio of the Education completion rate(%) in Estonia in 2006 to that in 2010?
Offer a terse response. 1.1. What is the ratio of the Education completion rate(%) in Venezuela in 2006 to that in 2010?
Provide a succinct answer. 0.91. What is the ratio of the Education completion rate(%) of Europe(all income levels) in 2006 to that in 2011?
Offer a very short reply. 0.99. What is the ratio of the Education completion rate(%) in Burundi in 2006 to that in 2011?
Offer a terse response. 0.4. What is the ratio of the Education completion rate(%) of Estonia in 2006 to that in 2011?
Ensure brevity in your answer.  1.14. What is the ratio of the Education completion rate(%) of Venezuela in 2006 to that in 2011?
Give a very brief answer. 0.92. What is the ratio of the Education completion rate(%) in Europe(all income levels) in 2006 to that in 2012?
Offer a terse response. 0.99. What is the ratio of the Education completion rate(%) of Burundi in 2006 to that in 2012?
Provide a short and direct response. 0.36. What is the ratio of the Education completion rate(%) of Estonia in 2006 to that in 2012?
Your answer should be very brief. 1.13. What is the ratio of the Education completion rate(%) in Venezuela in 2006 to that in 2012?
Keep it short and to the point. 0.9. What is the ratio of the Education completion rate(%) of Europe(all income levels) in 2006 to that in 2013?
Provide a succinct answer. 0.98. What is the ratio of the Education completion rate(%) of Burundi in 2006 to that in 2013?
Provide a succinct answer. 0.29. What is the ratio of the Education completion rate(%) of Estonia in 2006 to that in 2013?
Provide a succinct answer. 1.14. What is the ratio of the Education completion rate(%) in Venezuela in 2006 to that in 2013?
Make the answer very short. 0.89. What is the ratio of the Education completion rate(%) in Europe(all income levels) in 2008 to that in 2009?
Offer a very short reply. 1.02. What is the ratio of the Education completion rate(%) in Burundi in 2008 to that in 2009?
Give a very brief answer. 0.82. What is the ratio of the Education completion rate(%) of Estonia in 2008 to that in 2009?
Your answer should be very brief. 1.06. What is the ratio of the Education completion rate(%) in Europe(all income levels) in 2008 to that in 2010?
Provide a short and direct response. 0.98. What is the ratio of the Education completion rate(%) in Burundi in 2008 to that in 2010?
Provide a short and direct response. 0.7. What is the ratio of the Education completion rate(%) in Estonia in 2008 to that in 2010?
Keep it short and to the point. 1.07. What is the ratio of the Education completion rate(%) of Venezuela in 2008 to that in 2010?
Your response must be concise. 1.02. What is the ratio of the Education completion rate(%) of Europe(all income levels) in 2008 to that in 2011?
Make the answer very short. 0.98. What is the ratio of the Education completion rate(%) in Burundi in 2008 to that in 2011?
Your answer should be very brief. 0.61. What is the ratio of the Education completion rate(%) in Estonia in 2008 to that in 2011?
Keep it short and to the point. 1.11. What is the ratio of the Education completion rate(%) of Venezuela in 2008 to that in 2011?
Provide a succinct answer. 1.02. What is the ratio of the Education completion rate(%) of Europe(all income levels) in 2008 to that in 2012?
Your answer should be very brief. 0.99. What is the ratio of the Education completion rate(%) in Burundi in 2008 to that in 2012?
Offer a terse response. 0.56. What is the ratio of the Education completion rate(%) in Estonia in 2008 to that in 2012?
Ensure brevity in your answer.  1.1. What is the ratio of the Education completion rate(%) of Venezuela in 2008 to that in 2012?
Ensure brevity in your answer.  1. What is the ratio of the Education completion rate(%) in Europe(all income levels) in 2008 to that in 2013?
Give a very brief answer. 0.98. What is the ratio of the Education completion rate(%) in Burundi in 2008 to that in 2013?
Offer a terse response. 0.46. What is the ratio of the Education completion rate(%) of Estonia in 2008 to that in 2013?
Keep it short and to the point. 1.11. What is the ratio of the Education completion rate(%) in Venezuela in 2008 to that in 2013?
Give a very brief answer. 0.99. What is the ratio of the Education completion rate(%) in Europe(all income levels) in 2009 to that in 2010?
Your answer should be very brief. 0.96. What is the ratio of the Education completion rate(%) in Burundi in 2009 to that in 2010?
Provide a short and direct response. 0.86. What is the ratio of the Education completion rate(%) in Estonia in 2009 to that in 2010?
Your answer should be very brief. 1.01. What is the ratio of the Education completion rate(%) of Europe(all income levels) in 2009 to that in 2011?
Give a very brief answer. 0.96. What is the ratio of the Education completion rate(%) in Burundi in 2009 to that in 2011?
Offer a terse response. 0.75. What is the ratio of the Education completion rate(%) in Estonia in 2009 to that in 2011?
Make the answer very short. 1.04. What is the ratio of the Education completion rate(%) in Venezuela in 2009 to that in 2011?
Give a very brief answer. 1.02. What is the ratio of the Education completion rate(%) of Europe(all income levels) in 2009 to that in 2012?
Ensure brevity in your answer.  0.97. What is the ratio of the Education completion rate(%) in Burundi in 2009 to that in 2012?
Offer a terse response. 0.69. What is the ratio of the Education completion rate(%) of Estonia in 2009 to that in 2012?
Provide a succinct answer. 1.04. What is the ratio of the Education completion rate(%) in Europe(all income levels) in 2009 to that in 2013?
Your answer should be very brief. 0.96. What is the ratio of the Education completion rate(%) in Burundi in 2009 to that in 2013?
Your answer should be very brief. 0.56. What is the ratio of the Education completion rate(%) in Estonia in 2009 to that in 2013?
Give a very brief answer. 1.05. What is the ratio of the Education completion rate(%) in Venezuela in 2009 to that in 2013?
Offer a very short reply. 0.99. What is the ratio of the Education completion rate(%) of Burundi in 2010 to that in 2011?
Your answer should be compact. 0.88. What is the ratio of the Education completion rate(%) of Estonia in 2010 to that in 2011?
Keep it short and to the point. 1.03. What is the ratio of the Education completion rate(%) of Venezuela in 2010 to that in 2011?
Give a very brief answer. 1. What is the ratio of the Education completion rate(%) in Europe(all income levels) in 2010 to that in 2012?
Keep it short and to the point. 1.01. What is the ratio of the Education completion rate(%) of Burundi in 2010 to that in 2012?
Give a very brief answer. 0.8. What is the ratio of the Education completion rate(%) in Venezuela in 2010 to that in 2012?
Ensure brevity in your answer.  0.99. What is the ratio of the Education completion rate(%) of Burundi in 2010 to that in 2013?
Your response must be concise. 0.65. What is the ratio of the Education completion rate(%) of Estonia in 2010 to that in 2013?
Offer a terse response. 1.03. What is the ratio of the Education completion rate(%) in Venezuela in 2010 to that in 2013?
Give a very brief answer. 0.97. What is the ratio of the Education completion rate(%) of Burundi in 2011 to that in 2012?
Keep it short and to the point. 0.91. What is the ratio of the Education completion rate(%) in Estonia in 2011 to that in 2012?
Make the answer very short. 0.99. What is the ratio of the Education completion rate(%) of Venezuela in 2011 to that in 2012?
Your answer should be compact. 0.98. What is the ratio of the Education completion rate(%) of Burundi in 2011 to that in 2013?
Your response must be concise. 0.74. What is the ratio of the Education completion rate(%) of Venezuela in 2011 to that in 2013?
Give a very brief answer. 0.97. What is the ratio of the Education completion rate(%) in Burundi in 2012 to that in 2013?
Offer a very short reply. 0.81. What is the ratio of the Education completion rate(%) in Estonia in 2012 to that in 2013?
Keep it short and to the point. 1.01. What is the ratio of the Education completion rate(%) in Venezuela in 2012 to that in 2013?
Provide a short and direct response. 0.99. What is the difference between the highest and the second highest Education completion rate(%) of Europe(all income levels)?
Offer a terse response. 0.12. What is the difference between the highest and the second highest Education completion rate(%) of Burundi?
Provide a short and direct response. 3.87. What is the difference between the highest and the second highest Education completion rate(%) in Estonia?
Provide a succinct answer. 3.24. What is the difference between the highest and the second highest Education completion rate(%) in Venezuela?
Keep it short and to the point. 0.83. What is the difference between the highest and the lowest Education completion rate(%) in Europe(all income levels)?
Make the answer very short. 3.42. What is the difference between the highest and the lowest Education completion rate(%) of Burundi?
Offer a very short reply. 14.5. What is the difference between the highest and the lowest Education completion rate(%) of Estonia?
Make the answer very short. 13.79. What is the difference between the highest and the lowest Education completion rate(%) in Venezuela?
Offer a very short reply. 11.49. 